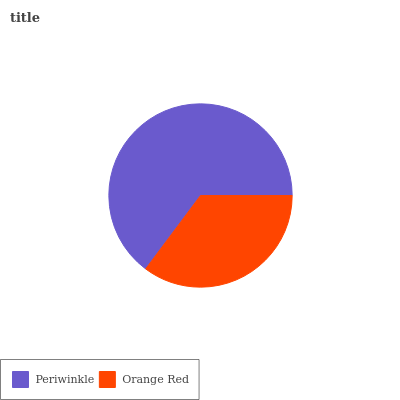Is Orange Red the minimum?
Answer yes or no. Yes. Is Periwinkle the maximum?
Answer yes or no. Yes. Is Orange Red the maximum?
Answer yes or no. No. Is Periwinkle greater than Orange Red?
Answer yes or no. Yes. Is Orange Red less than Periwinkle?
Answer yes or no. Yes. Is Orange Red greater than Periwinkle?
Answer yes or no. No. Is Periwinkle less than Orange Red?
Answer yes or no. No. Is Periwinkle the high median?
Answer yes or no. Yes. Is Orange Red the low median?
Answer yes or no. Yes. Is Orange Red the high median?
Answer yes or no. No. Is Periwinkle the low median?
Answer yes or no. No. 